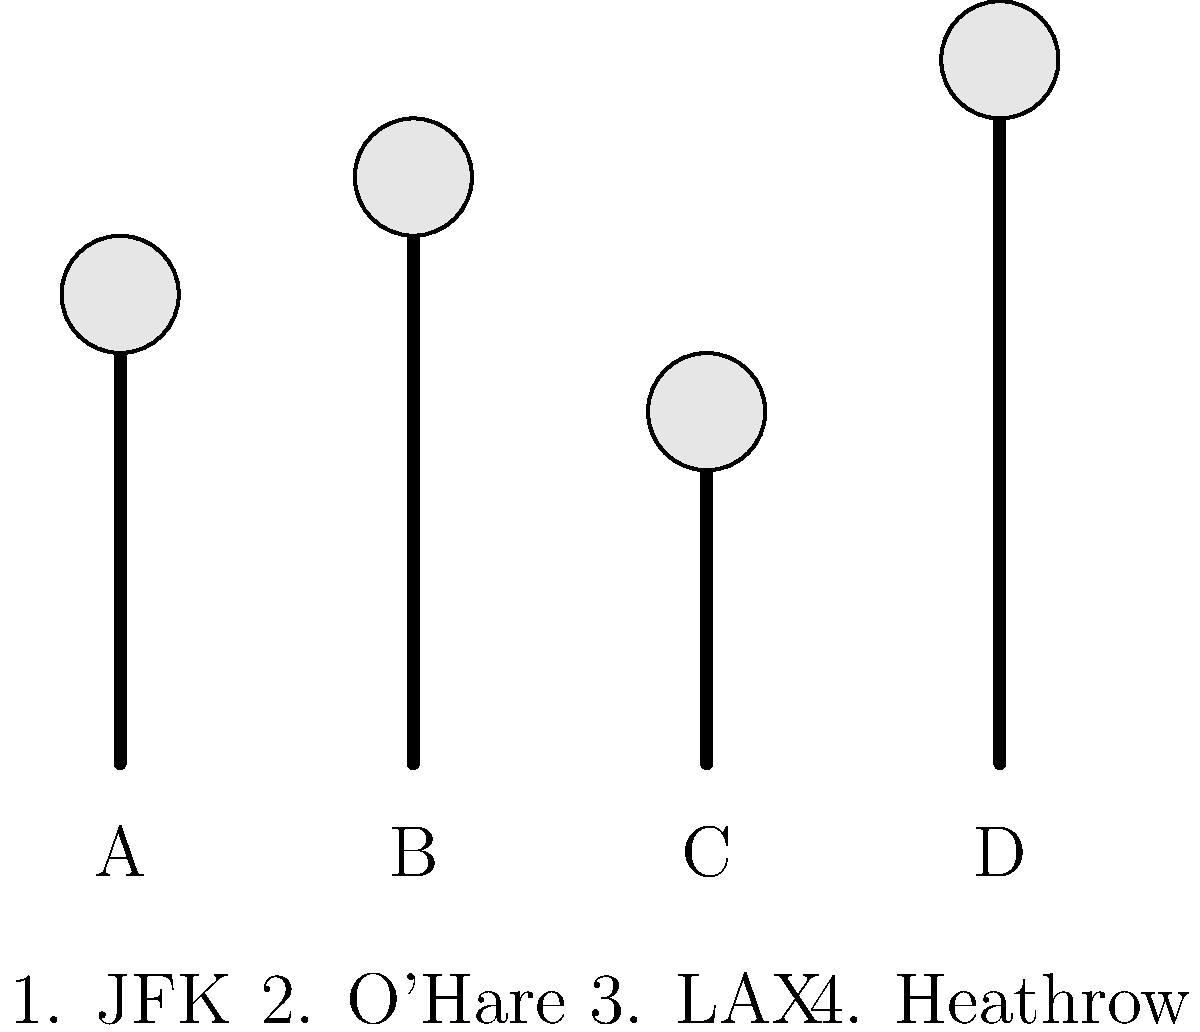Match the air traffic control tower designs (A, B, C, D) to their corresponding airports (1, 2, 3, 4). Which tower belongs to O'Hare International Airport? Let's approach this step-by-step:

1. First, we need to understand that air traffic control towers are designed differently for each airport, often reflecting the airport's size and importance.

2. Looking at the diagram, we see four different tower designs:
   A: Medium height
   B: Tall
   C: Shortest
   D: Tallest

3. Now, let's consider what we know about the airports:
   - JFK (New York) is a major international hub
   - O'Hare (Chicago) is one of the busiest airports in the world
   - LAX (Los Angeles) is another major international hub
   - Heathrow (London) is one of the busiest airports in Europe

4. Given their importance, we can assume that these airports would have taller control towers for better visibility.

5. O'Hare, being one of the busiest airports, would likely have one of the taller towers. In this diagram, that would be tower B, which is the second tallest.

6. The tallest tower (D) might correspond to Heathrow, while the medium height tower (A) could be JFK or LAX. The shortest tower (C) might be for a smaller airport, but in this case, it's likely LAX as it's the only option left.

Therefore, tower B most likely corresponds to O'Hare International Airport.
Answer: B 